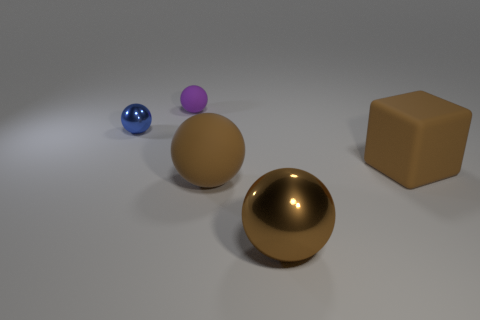Is the shape of the large brown metal object the same as the matte object that is behind the small shiny thing?
Your answer should be compact. Yes. Is there anything else that has the same color as the tiny metallic sphere?
Your answer should be very brief. No. There is a big matte thing to the right of the big metal thing; is its color the same as the big ball to the right of the large rubber sphere?
Your answer should be very brief. Yes. Are any big green rubber blocks visible?
Keep it short and to the point. No. Are there any small purple cubes that have the same material as the blue ball?
Offer a terse response. No. Is there any other thing that is made of the same material as the big cube?
Offer a very short reply. Yes. What color is the small metal ball?
Your answer should be compact. Blue. What is the shape of the large matte thing that is the same color as the large block?
Keep it short and to the point. Sphere. What is the color of the rubber object that is the same size as the blue metallic sphere?
Give a very brief answer. Purple. What number of metallic things are either big gray spheres or blue spheres?
Provide a short and direct response. 1. 